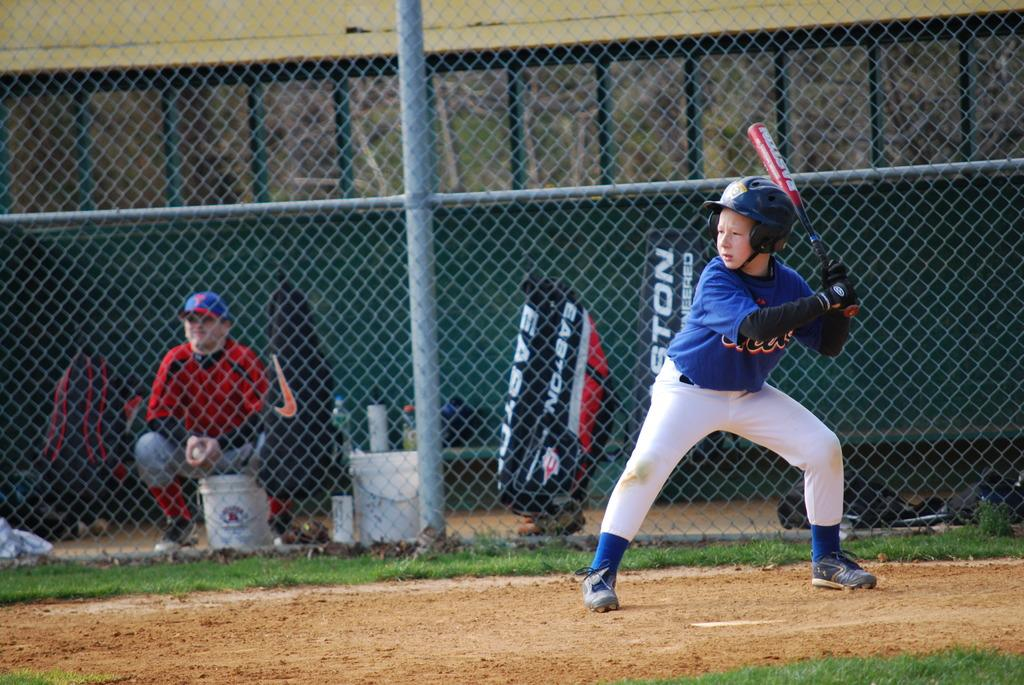Provide a one-sentence caption for the provided image. A baseball player batting a ball and a bag with Easton on it in the background. 